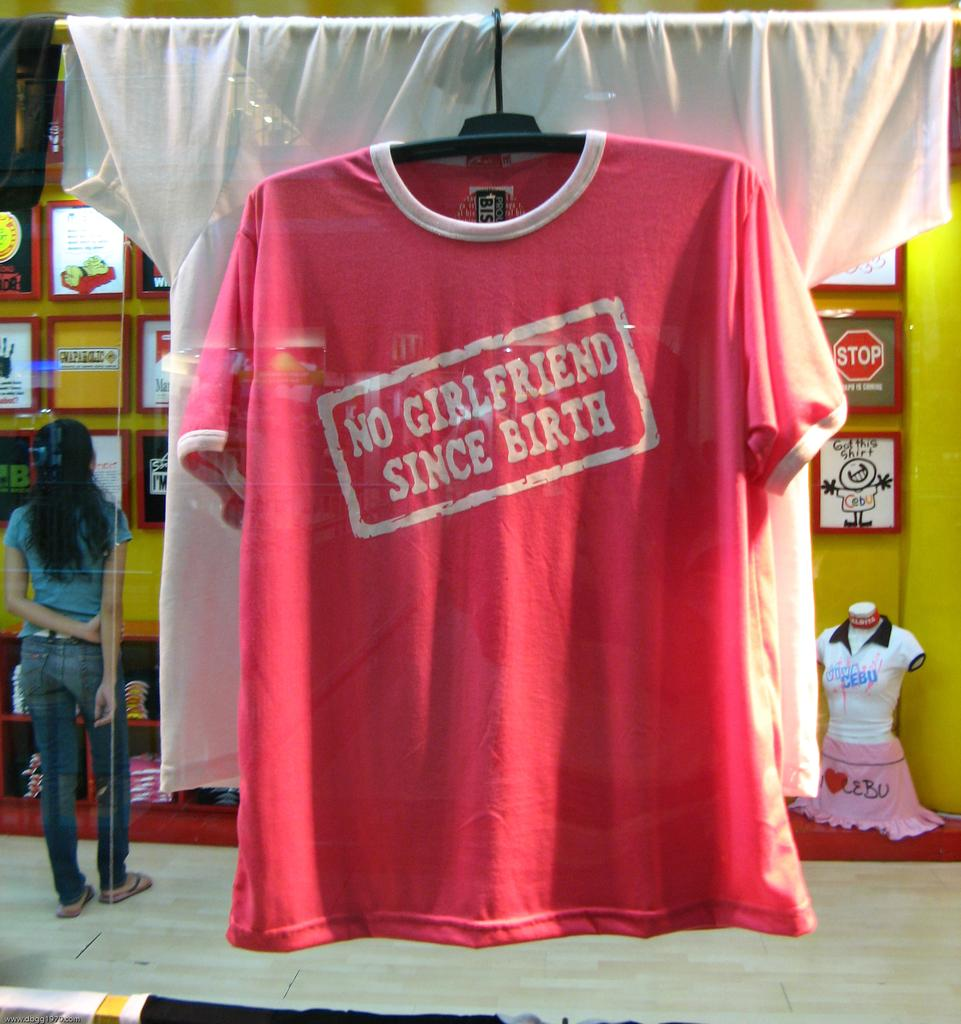<image>
Summarize the visual content of the image. A t-shirt saying "No girlfriend since birth" hangs in a store window. 